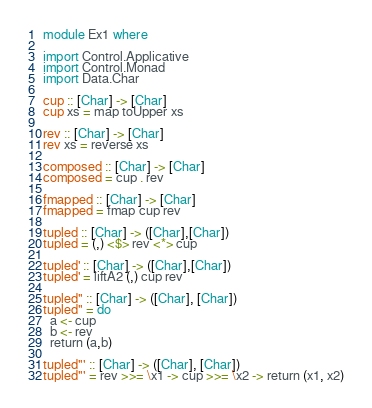Convert code to text. <code><loc_0><loc_0><loc_500><loc_500><_Haskell_>module Ex1 where

import Control.Applicative
import Control.Monad
import Data.Char

cup :: [Char] -> [Char]
cup xs = map toUpper xs

rev :: [Char] -> [Char]
rev xs = reverse xs

composed :: [Char] -> [Char]
composed = cup . rev

fmapped :: [Char] -> [Char]
fmapped = fmap cup rev

tupled :: [Char] -> ([Char],[Char])
tupled = (,) <$> rev <*> cup

tupled' :: [Char] -> ([Char],[Char])
tupled' = liftA2 (,) cup rev

tupled'' :: [Char] -> ([Char], [Char])
tupled'' = do
  a <- cup
  b <- rev
  return (a,b)

tupled''' :: [Char] -> ([Char], [Char])
tupled''' = rev >>= \x1 -> cup >>= \x2 -> return (x1, x2)
</code> 